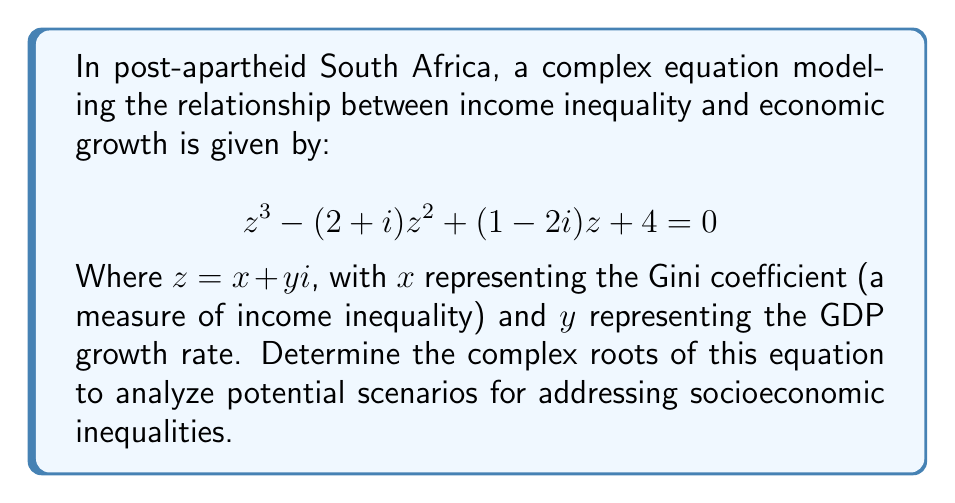Can you solve this math problem? To find the complex roots of this cubic equation, we can use the following steps:

1) First, let's identify the coefficients:
   $a = 1$
   $b = -(2+i)$
   $c = 1-2i$
   $d = 4$

2) We can use Cardano's formula for cubic equations. Let's calculate the following:

   $p = \frac{3ac-b^2}{3a^2} = \frac{3(1)(1-2i) - (-2-i)^2}{3(1)^2} = \frac{3-6i - (4-i^2)}{3} = \frac{-1-6i+1}{3} = -2i$

   $q = \frac{2b^3-9abc+27a^2d}{27a^3} = \frac{2(-2-i)^3 - 9(1)(-2-i)(1-2i) + 27(1)^2(4)}{27(1)^3}$
      $= \frac{-8-12i+6i^2+i^3 + 18+9i-36i+18i^2 + 108}{27} = \frac{118+6i}{27} = \frac{59}{27} + \frac{i}{3}$

3) Now, we calculate:
   $D = \sqrt[3]{\frac{q}{2} + \sqrt{\frac{q^2}{4} + \frac{p^3}{27}}} + \sqrt[3]{\frac{q}{2} - \sqrt{\frac{q^2}{4} + \frac{p^3}{27}}}$

   Where $\frac{q}{2} = \frac{59}{54} + \frac{i}{6}$ and $\frac{p^3}{27} = -\frac{8i}{27}$

   $\frac{q^2}{4} + \frac{p^3}{27} = (\frac{59}{54} + \frac{i}{6})^2 - \frac{8i}{27} = \frac{3481}{2916} + \frac{59i}{162} - \frac{1}{36} - \frac{8i}{27} = \frac{3445}{2916} + \frac{35i}{162}$

   $\sqrt{\frac{q^2}{4} + \frac{p^3}{27}} \approx 1.0115 + 0.1097i$

   $D \approx \sqrt[3]{1.5972 + 0.2764i} + \sqrt[3]{0.5743 - 0.0569i} \approx 1.3473 + 0.1046i + 0.8617 - 0.0220i = 2.2090 + 0.0826i$

4) The roots are given by:
   $z_1 = D - \frac{b}{3a} = (2.2090 + 0.0826i) - \frac{-2-i}{3} = 2.8757 + 0.4159i$
   $z_2 = -\frac{D}{2} - \frac{b}{3a} + i\frac{\sqrt{3}}{2}D = -0.4379 + 1.2747i$
   $z_3 = -\frac{D}{2} - \frac{b}{3a} - i\frac{\sqrt{3}}{2}D = -0.4379 - 1.2747i$
Answer: The complex roots of the equation are:
$z_1 \approx 2.8757 + 0.4159i$
$z_2 \approx -0.4379 + 1.2747i$
$z_3 \approx -0.4379 - 1.2747i$ 